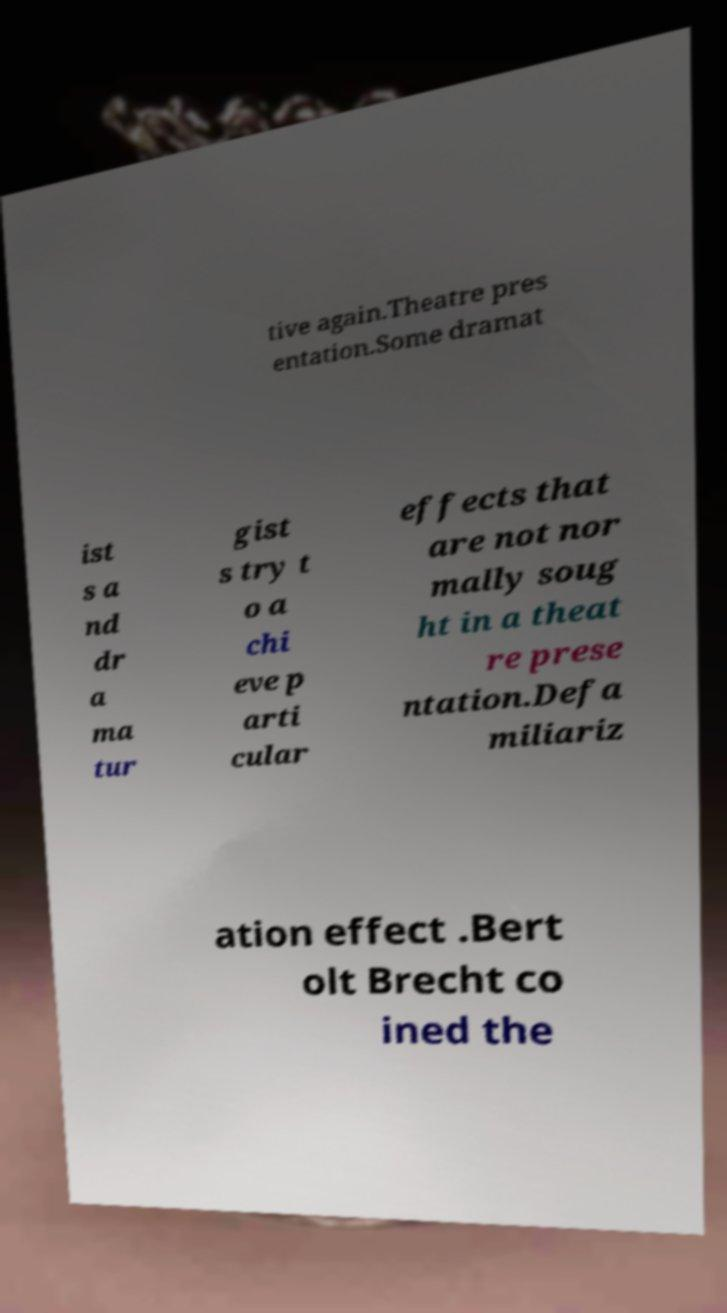There's text embedded in this image that I need extracted. Can you transcribe it verbatim? tive again.Theatre pres entation.Some dramat ist s a nd dr a ma tur gist s try t o a chi eve p arti cular effects that are not nor mally soug ht in a theat re prese ntation.Defa miliariz ation effect .Bert olt Brecht co ined the 